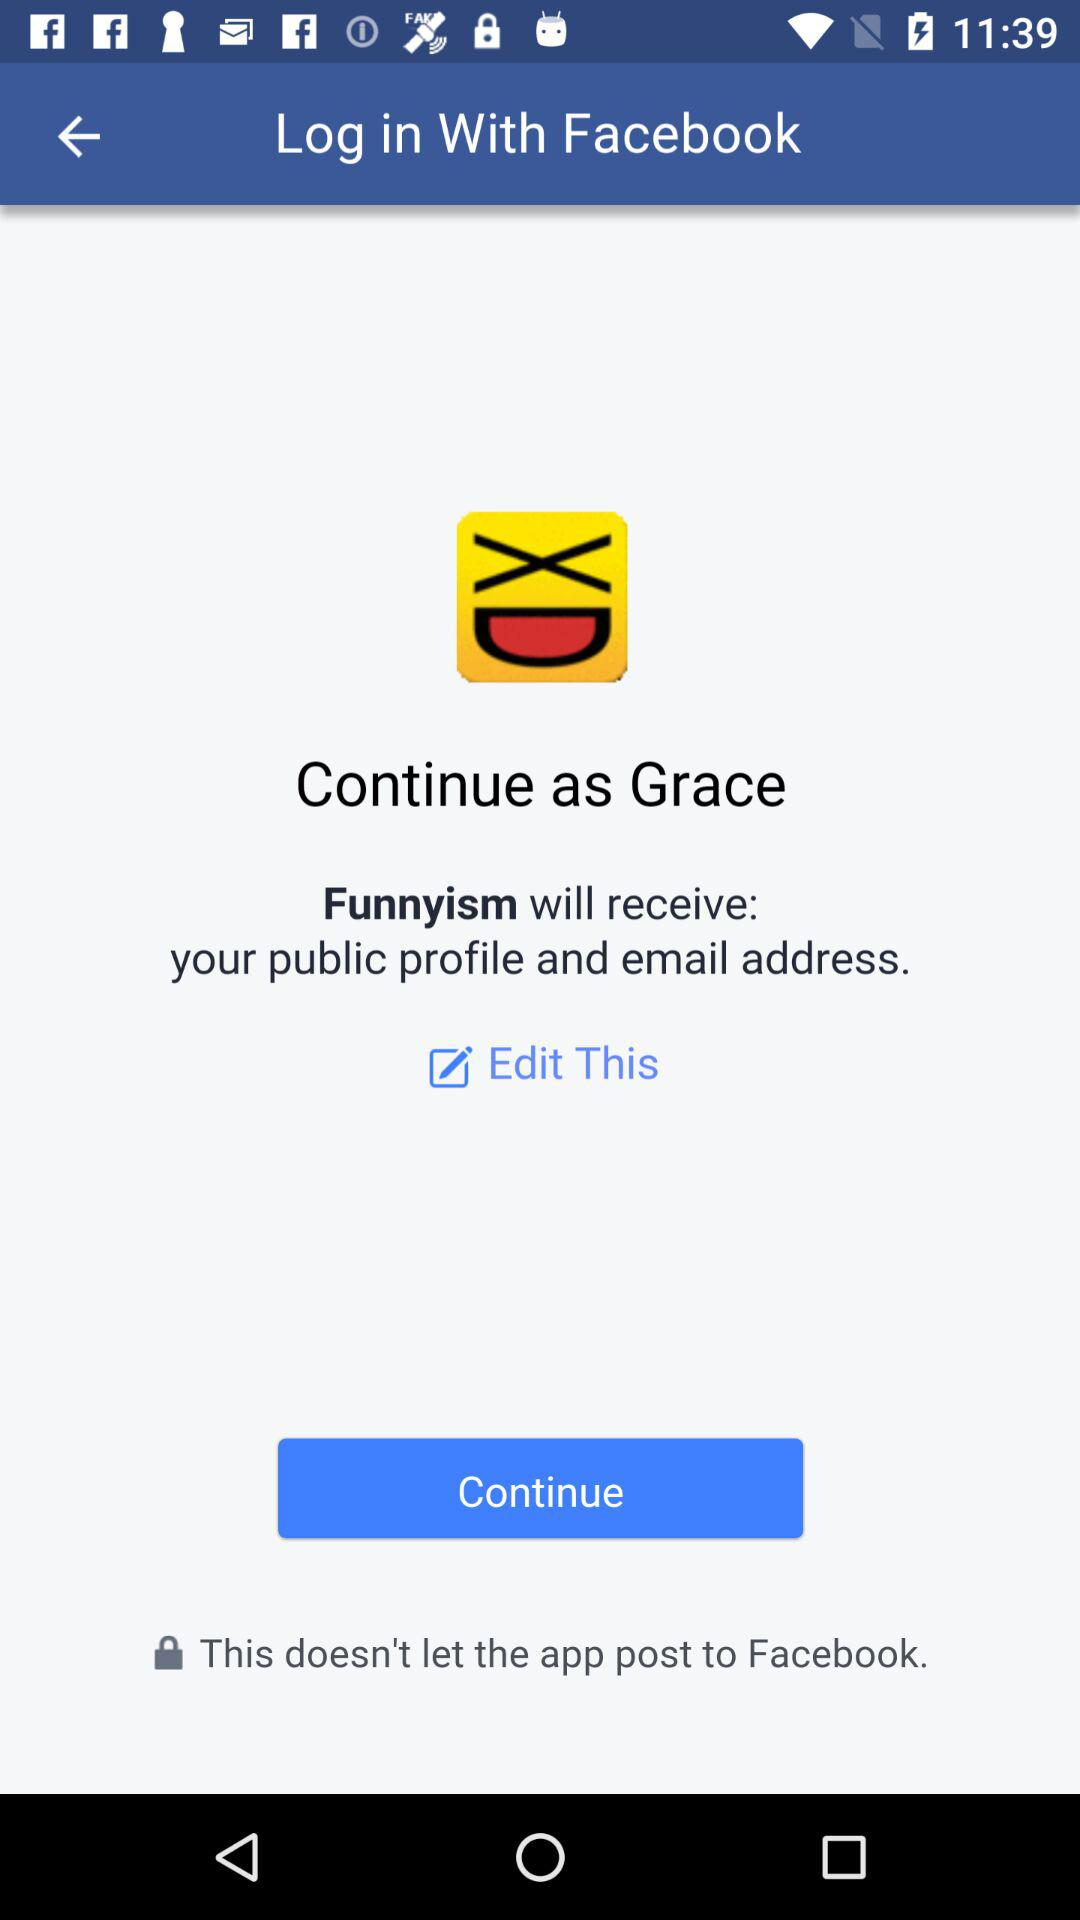What is the login name? The login name is Grace. 